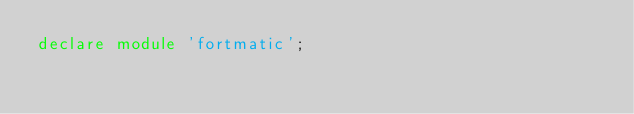Convert code to text. <code><loc_0><loc_0><loc_500><loc_500><_TypeScript_>declare module 'fortmatic';
</code> 